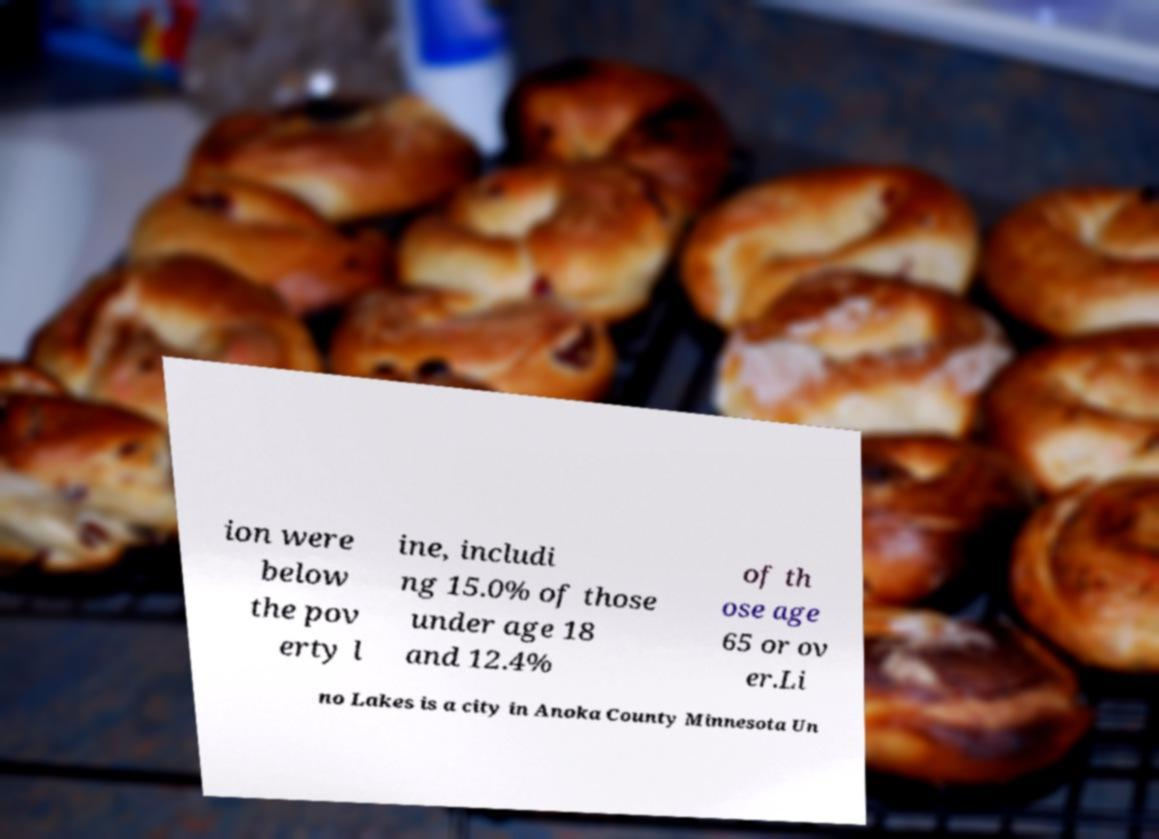For documentation purposes, I need the text within this image transcribed. Could you provide that? ion were below the pov erty l ine, includi ng 15.0% of those under age 18 and 12.4% of th ose age 65 or ov er.Li no Lakes is a city in Anoka County Minnesota Un 